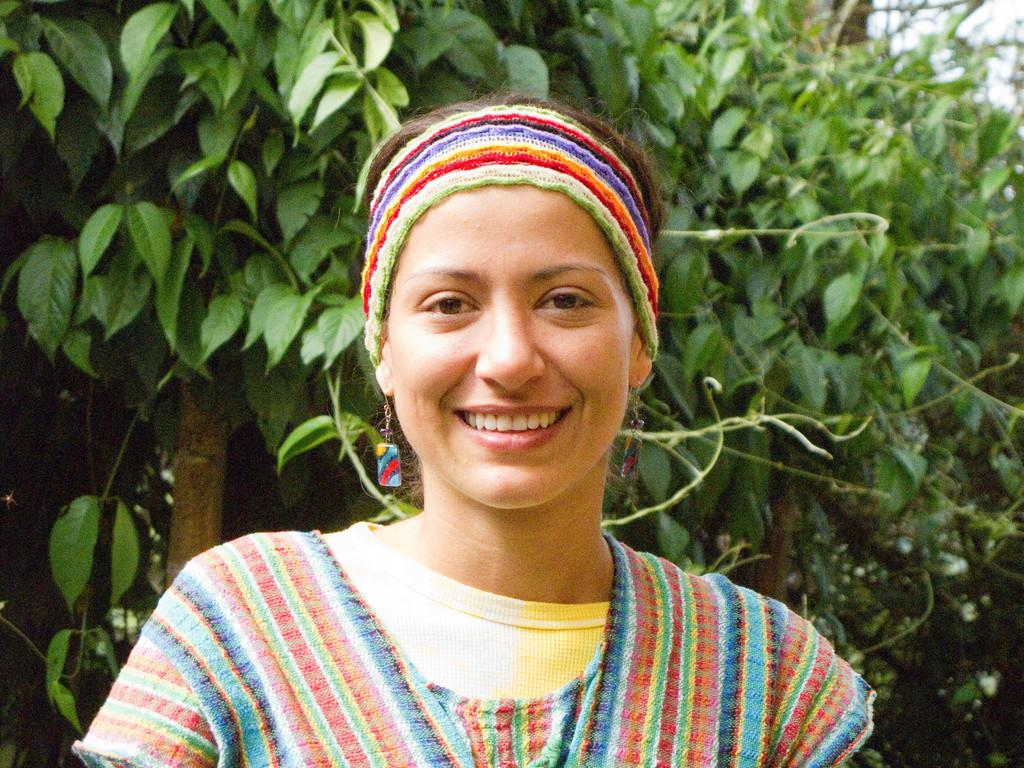Who is present in the image? There is a woman in the image. What type of natural environment can be seen in the image? There are trees in the image. What part of the natural environment is visible in the image? The sky is visible in the image. Based on the visibility of the sky and trees, can we determine the time of day the image was taken? The image was likely taken during the day, as the sky and trees are clearly visible. What type of wheel can be seen in the image? There is no wheel present in the image. What agreement was made between the woman and the trees in the image? There is no agreement present in the image, as it is a photograph and not a conversation or negotiation. 